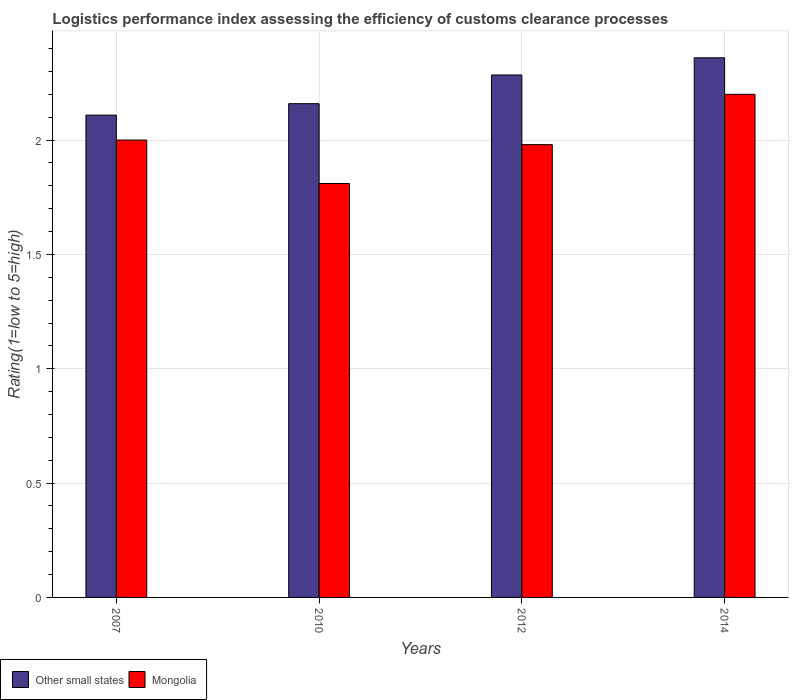Are the number of bars on each tick of the X-axis equal?
Provide a short and direct response. Yes. How many bars are there on the 1st tick from the right?
Keep it short and to the point. 2. What is the label of the 1st group of bars from the left?
Provide a succinct answer. 2007. What is the Logistic performance index in Mongolia in 2010?
Offer a terse response. 1.81. Across all years, what is the minimum Logistic performance index in Other small states?
Provide a succinct answer. 2.11. In which year was the Logistic performance index in Mongolia maximum?
Provide a short and direct response. 2014. What is the total Logistic performance index in Other small states in the graph?
Ensure brevity in your answer.  8.91. What is the difference between the Logistic performance index in Mongolia in 2007 and that in 2014?
Give a very brief answer. -0.2. What is the difference between the Logistic performance index in Other small states in 2010 and the Logistic performance index in Mongolia in 2014?
Make the answer very short. -0.04. What is the average Logistic performance index in Other small states per year?
Keep it short and to the point. 2.23. In the year 2012, what is the difference between the Logistic performance index in Other small states and Logistic performance index in Mongolia?
Make the answer very short. 0.3. In how many years, is the Logistic performance index in Other small states greater than 0.5?
Offer a very short reply. 4. What is the ratio of the Logistic performance index in Mongolia in 2010 to that in 2014?
Your answer should be compact. 0.82. Is the Logistic performance index in Other small states in 2010 less than that in 2012?
Provide a short and direct response. Yes. What is the difference between the highest and the second highest Logistic performance index in Other small states?
Give a very brief answer. 0.08. What is the difference between the highest and the lowest Logistic performance index in Mongolia?
Ensure brevity in your answer.  0.39. Is the sum of the Logistic performance index in Other small states in 2007 and 2014 greater than the maximum Logistic performance index in Mongolia across all years?
Keep it short and to the point. Yes. What does the 2nd bar from the left in 2007 represents?
Your answer should be very brief. Mongolia. What does the 1st bar from the right in 2012 represents?
Keep it short and to the point. Mongolia. How many bars are there?
Give a very brief answer. 8. Are all the bars in the graph horizontal?
Provide a short and direct response. No. How many years are there in the graph?
Your response must be concise. 4. What is the difference between two consecutive major ticks on the Y-axis?
Offer a very short reply. 0.5. Does the graph contain grids?
Keep it short and to the point. Yes. Where does the legend appear in the graph?
Make the answer very short. Bottom left. How many legend labels are there?
Give a very brief answer. 2. How are the legend labels stacked?
Offer a terse response. Horizontal. What is the title of the graph?
Provide a short and direct response. Logistics performance index assessing the efficiency of customs clearance processes. Does "Saudi Arabia" appear as one of the legend labels in the graph?
Offer a terse response. No. What is the label or title of the Y-axis?
Give a very brief answer. Rating(1=low to 5=high). What is the Rating(1=low to 5=high) of Other small states in 2007?
Give a very brief answer. 2.11. What is the Rating(1=low to 5=high) in Mongolia in 2007?
Offer a terse response. 2. What is the Rating(1=low to 5=high) in Other small states in 2010?
Keep it short and to the point. 2.16. What is the Rating(1=low to 5=high) in Mongolia in 2010?
Make the answer very short. 1.81. What is the Rating(1=low to 5=high) of Other small states in 2012?
Your answer should be compact. 2.28. What is the Rating(1=low to 5=high) in Mongolia in 2012?
Your answer should be very brief. 1.98. What is the Rating(1=low to 5=high) of Other small states in 2014?
Keep it short and to the point. 2.36. What is the Rating(1=low to 5=high) in Mongolia in 2014?
Your answer should be compact. 2.2. Across all years, what is the maximum Rating(1=low to 5=high) of Other small states?
Keep it short and to the point. 2.36. Across all years, what is the maximum Rating(1=low to 5=high) of Mongolia?
Keep it short and to the point. 2.2. Across all years, what is the minimum Rating(1=low to 5=high) of Other small states?
Your response must be concise. 2.11. Across all years, what is the minimum Rating(1=low to 5=high) in Mongolia?
Offer a terse response. 1.81. What is the total Rating(1=low to 5=high) in Other small states in the graph?
Your answer should be very brief. 8.91. What is the total Rating(1=low to 5=high) in Mongolia in the graph?
Your answer should be compact. 7.99. What is the difference between the Rating(1=low to 5=high) of Mongolia in 2007 and that in 2010?
Your answer should be compact. 0.19. What is the difference between the Rating(1=low to 5=high) in Other small states in 2007 and that in 2012?
Provide a succinct answer. -0.18. What is the difference between the Rating(1=low to 5=high) of Other small states in 2007 and that in 2014?
Your answer should be very brief. -0.25. What is the difference between the Rating(1=low to 5=high) of Mongolia in 2007 and that in 2014?
Ensure brevity in your answer.  -0.2. What is the difference between the Rating(1=low to 5=high) of Other small states in 2010 and that in 2012?
Provide a succinct answer. -0.13. What is the difference between the Rating(1=low to 5=high) in Mongolia in 2010 and that in 2012?
Your response must be concise. -0.17. What is the difference between the Rating(1=low to 5=high) in Other small states in 2010 and that in 2014?
Give a very brief answer. -0.2. What is the difference between the Rating(1=low to 5=high) in Mongolia in 2010 and that in 2014?
Provide a succinct answer. -0.39. What is the difference between the Rating(1=low to 5=high) of Other small states in 2012 and that in 2014?
Give a very brief answer. -0.07. What is the difference between the Rating(1=low to 5=high) of Mongolia in 2012 and that in 2014?
Make the answer very short. -0.22. What is the difference between the Rating(1=low to 5=high) of Other small states in 2007 and the Rating(1=low to 5=high) of Mongolia in 2010?
Offer a terse response. 0.3. What is the difference between the Rating(1=low to 5=high) of Other small states in 2007 and the Rating(1=low to 5=high) of Mongolia in 2012?
Your answer should be compact. 0.13. What is the difference between the Rating(1=low to 5=high) in Other small states in 2007 and the Rating(1=low to 5=high) in Mongolia in 2014?
Ensure brevity in your answer.  -0.09. What is the difference between the Rating(1=low to 5=high) of Other small states in 2010 and the Rating(1=low to 5=high) of Mongolia in 2012?
Your answer should be very brief. 0.18. What is the difference between the Rating(1=low to 5=high) of Other small states in 2010 and the Rating(1=low to 5=high) of Mongolia in 2014?
Ensure brevity in your answer.  -0.04. What is the difference between the Rating(1=low to 5=high) in Other small states in 2012 and the Rating(1=low to 5=high) in Mongolia in 2014?
Offer a very short reply. 0.08. What is the average Rating(1=low to 5=high) in Other small states per year?
Your answer should be compact. 2.23. What is the average Rating(1=low to 5=high) in Mongolia per year?
Keep it short and to the point. 2. In the year 2007, what is the difference between the Rating(1=low to 5=high) in Other small states and Rating(1=low to 5=high) in Mongolia?
Ensure brevity in your answer.  0.11. In the year 2010, what is the difference between the Rating(1=low to 5=high) of Other small states and Rating(1=low to 5=high) of Mongolia?
Make the answer very short. 0.35. In the year 2012, what is the difference between the Rating(1=low to 5=high) in Other small states and Rating(1=low to 5=high) in Mongolia?
Make the answer very short. 0.3. In the year 2014, what is the difference between the Rating(1=low to 5=high) in Other small states and Rating(1=low to 5=high) in Mongolia?
Your answer should be compact. 0.16. What is the ratio of the Rating(1=low to 5=high) in Other small states in 2007 to that in 2010?
Provide a short and direct response. 0.98. What is the ratio of the Rating(1=low to 5=high) of Mongolia in 2007 to that in 2010?
Your response must be concise. 1.1. What is the ratio of the Rating(1=low to 5=high) in Other small states in 2007 to that in 2012?
Keep it short and to the point. 0.92. What is the ratio of the Rating(1=low to 5=high) of Mongolia in 2007 to that in 2012?
Make the answer very short. 1.01. What is the ratio of the Rating(1=low to 5=high) in Other small states in 2007 to that in 2014?
Ensure brevity in your answer.  0.89. What is the ratio of the Rating(1=low to 5=high) of Mongolia in 2007 to that in 2014?
Provide a short and direct response. 0.91. What is the ratio of the Rating(1=low to 5=high) in Other small states in 2010 to that in 2012?
Give a very brief answer. 0.95. What is the ratio of the Rating(1=low to 5=high) in Mongolia in 2010 to that in 2012?
Make the answer very short. 0.91. What is the ratio of the Rating(1=low to 5=high) of Other small states in 2010 to that in 2014?
Your response must be concise. 0.92. What is the ratio of the Rating(1=low to 5=high) in Mongolia in 2010 to that in 2014?
Make the answer very short. 0.82. What is the ratio of the Rating(1=low to 5=high) of Other small states in 2012 to that in 2014?
Offer a very short reply. 0.97. What is the ratio of the Rating(1=low to 5=high) of Mongolia in 2012 to that in 2014?
Provide a succinct answer. 0.9. What is the difference between the highest and the second highest Rating(1=low to 5=high) of Other small states?
Your response must be concise. 0.07. What is the difference between the highest and the second highest Rating(1=low to 5=high) of Mongolia?
Offer a very short reply. 0.2. What is the difference between the highest and the lowest Rating(1=low to 5=high) in Other small states?
Ensure brevity in your answer.  0.25. What is the difference between the highest and the lowest Rating(1=low to 5=high) in Mongolia?
Your answer should be very brief. 0.39. 